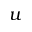Convert formula to latex. <formula><loc_0><loc_0><loc_500><loc_500>u</formula> 